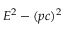Convert formula to latex. <formula><loc_0><loc_0><loc_500><loc_500>E ^ { 2 } - ( p c ) ^ { 2 }</formula> 